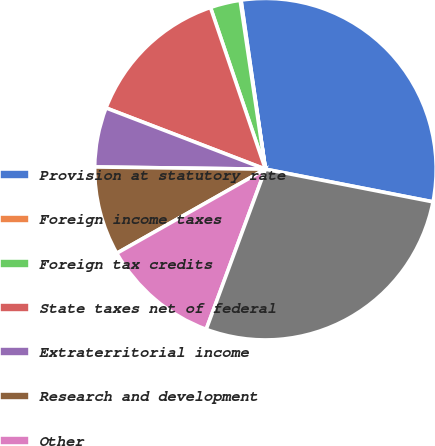Convert chart. <chart><loc_0><loc_0><loc_500><loc_500><pie_chart><fcel>Provision at statutory rate<fcel>Foreign income taxes<fcel>Foreign tax credits<fcel>State taxes net of federal<fcel>Extraterritorial income<fcel>Research and development<fcel>Other<fcel>Provision for income taxes<nl><fcel>30.35%<fcel>0.08%<fcel>2.85%<fcel>13.95%<fcel>5.63%<fcel>8.4%<fcel>11.17%<fcel>27.57%<nl></chart> 